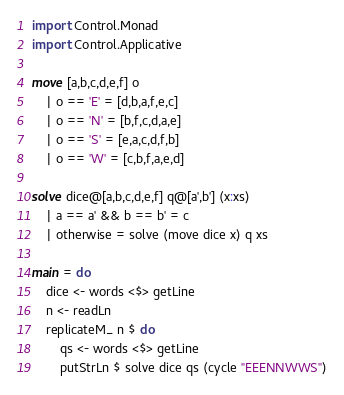Convert code to text. <code><loc_0><loc_0><loc_500><loc_500><_Haskell_>import Control.Monad
import Control.Applicative

move [a,b,c,d,e,f] o
	| o == 'E' = [d,b,a,f,e,c]
	| o == 'N' = [b,f,c,d,a,e]
	| o == 'S' = [e,a,c,d,f,b]
	| o == 'W' = [c,b,f,a,e,d]

solve dice@[a,b,c,d,e,f] q@[a',b'] (x:xs)
	| a == a' && b == b' = c
	| otherwise = solve (move dice x) q xs

main = do
	dice <- words <$> getLine
	n <- readLn
	replicateM_ n $ do
		qs <- words <$> getLine
		putStrLn $ solve dice qs (cycle "EEENNWWS")</code> 